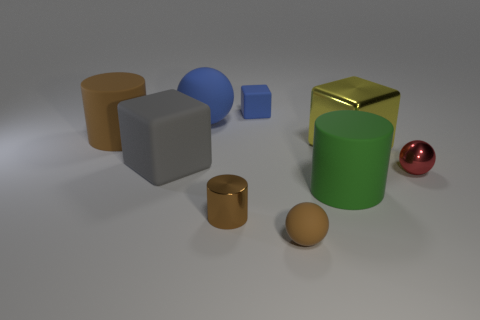What is the material of the small block that is the same color as the big matte ball?
Your answer should be compact. Rubber. There is a ball that is the same color as the tiny block; what is its size?
Your response must be concise. Large. What number of things are tiny gray metallic objects or big gray rubber blocks?
Offer a very short reply. 1. What size is the shiny object that is the same shape as the green rubber object?
Give a very brief answer. Small. The metallic cylinder is what size?
Provide a short and direct response. Small. Is the number of big yellow metal objects that are behind the brown matte cylinder greater than the number of big rubber objects?
Your answer should be compact. No. Is the color of the small rubber object that is behind the big green matte thing the same as the rubber sphere on the left side of the small brown rubber ball?
Your answer should be very brief. Yes. There is a big cylinder behind the rubber cube that is in front of the brown matte thing that is to the left of the large gray cube; what is its material?
Offer a very short reply. Rubber. Are there more brown shiny cylinders than metal objects?
Ensure brevity in your answer.  No. Is there any other thing that is the same color as the big shiny block?
Your response must be concise. No. 